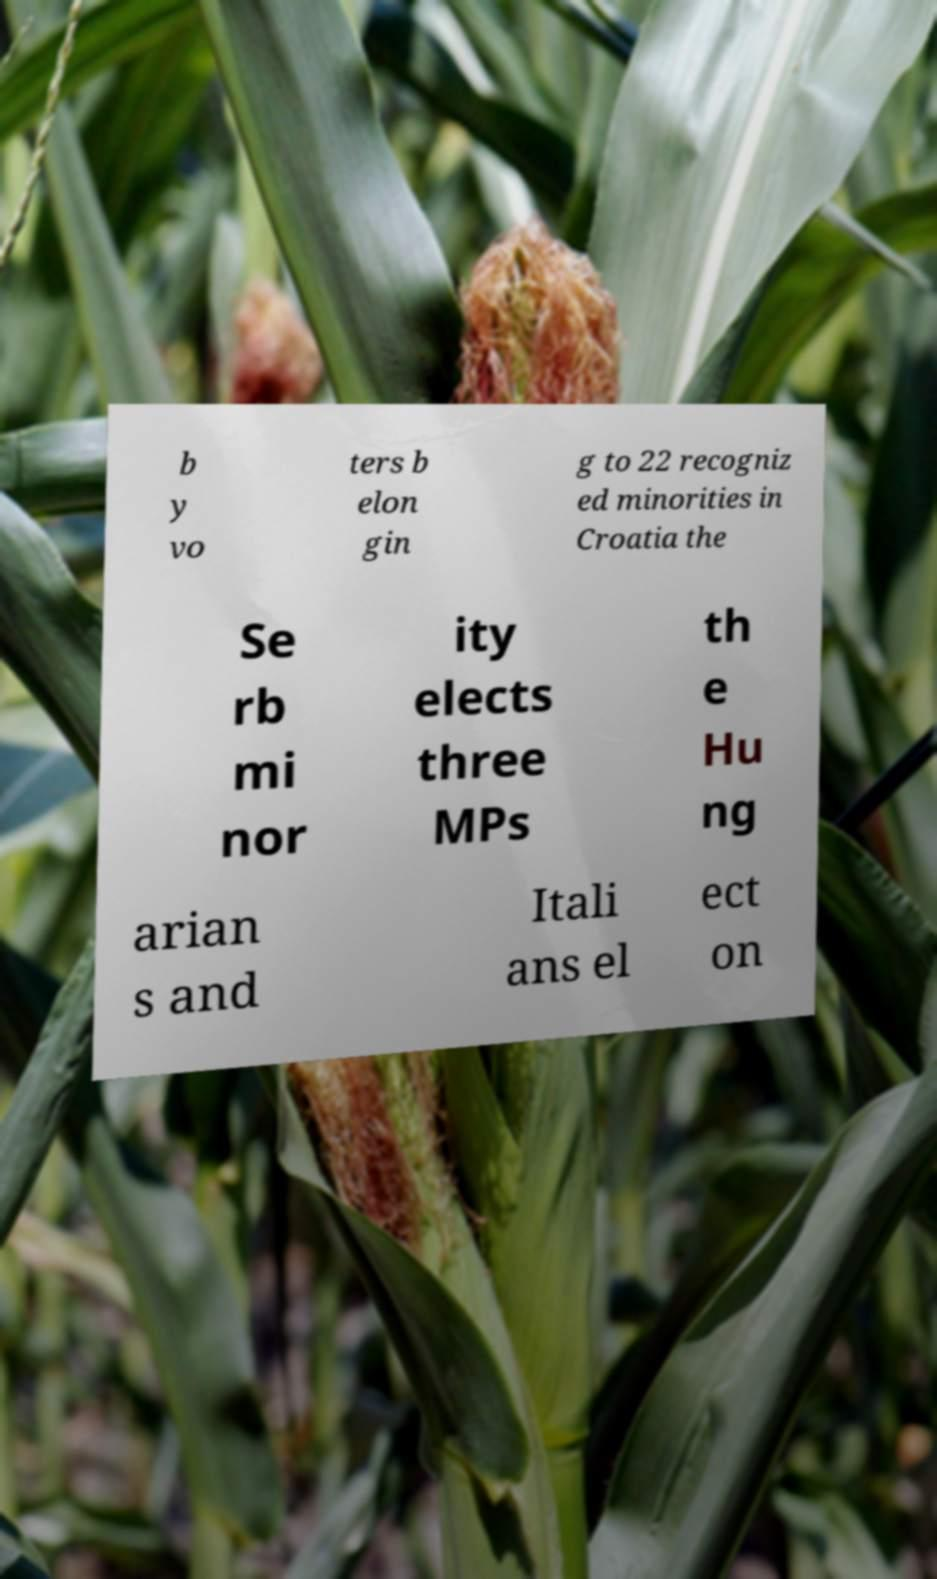Please identify and transcribe the text found in this image. b y vo ters b elon gin g to 22 recogniz ed minorities in Croatia the Se rb mi nor ity elects three MPs th e Hu ng arian s and Itali ans el ect on 